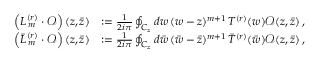Convert formula to latex. <formula><loc_0><loc_0><loc_500><loc_500>\begin{array} { r l } { \left ( L _ { \, m } ^ { ( r ) } \cdot \mathcal { O } \right ) ( z , \bar { z } ) } & { \colon = \frac { 1 } { 2 i \pi } \oint _ { C _ { z } } d w \, ( w - z ) ^ { m + 1 } \, T ^ { ( r ) } ( w ) \mathcal { O } ( z , \bar { z } ) \, , } \\ { \left ( \bar { L } _ { \, m } ^ { ( r ) } \cdot \mathcal { O } \right ) ( z , \bar { z } ) } & { \colon = \frac { 1 } { 2 i \pi } \oint _ { C _ { z } } d \bar { w } \, ( \bar { w } - \bar { z } ) ^ { m + 1 } \, \bar { T } ^ { ( r ) } ( \bar { w } ) \mathcal { O } ( z , \bar { z } ) \, , } \end{array}</formula> 